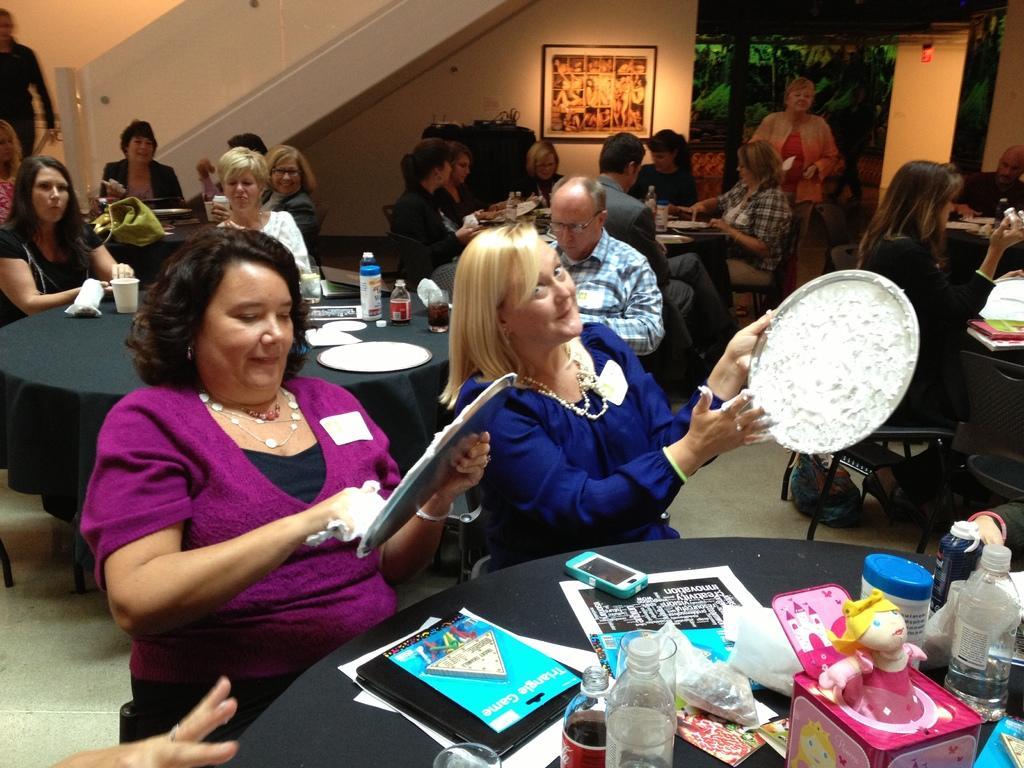In one or two sentences, can you explain what this image depicts? In this picture we can see some persons sitting on chair and in front of them there is table and on table we can see plate, bottle, glass, plastic covers, books, mobile, toy and in the background we can see wall, frame, tree. 